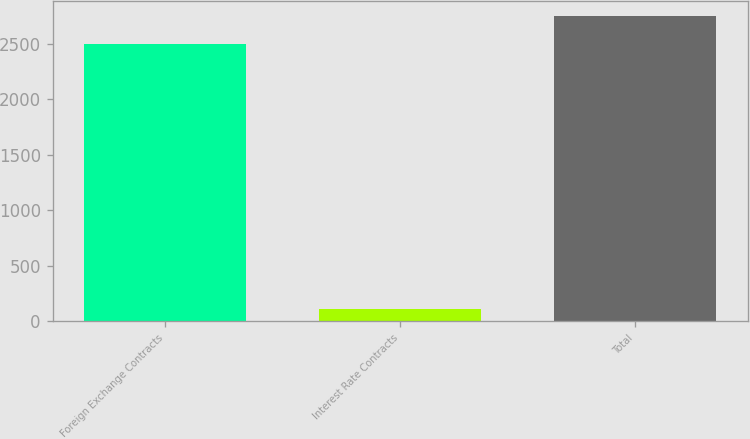Convert chart to OTSL. <chart><loc_0><loc_0><loc_500><loc_500><bar_chart><fcel>Foreign Exchange Contracts<fcel>Interest Rate Contracts<fcel>Total<nl><fcel>2500.4<fcel>108.5<fcel>2750.44<nl></chart> 